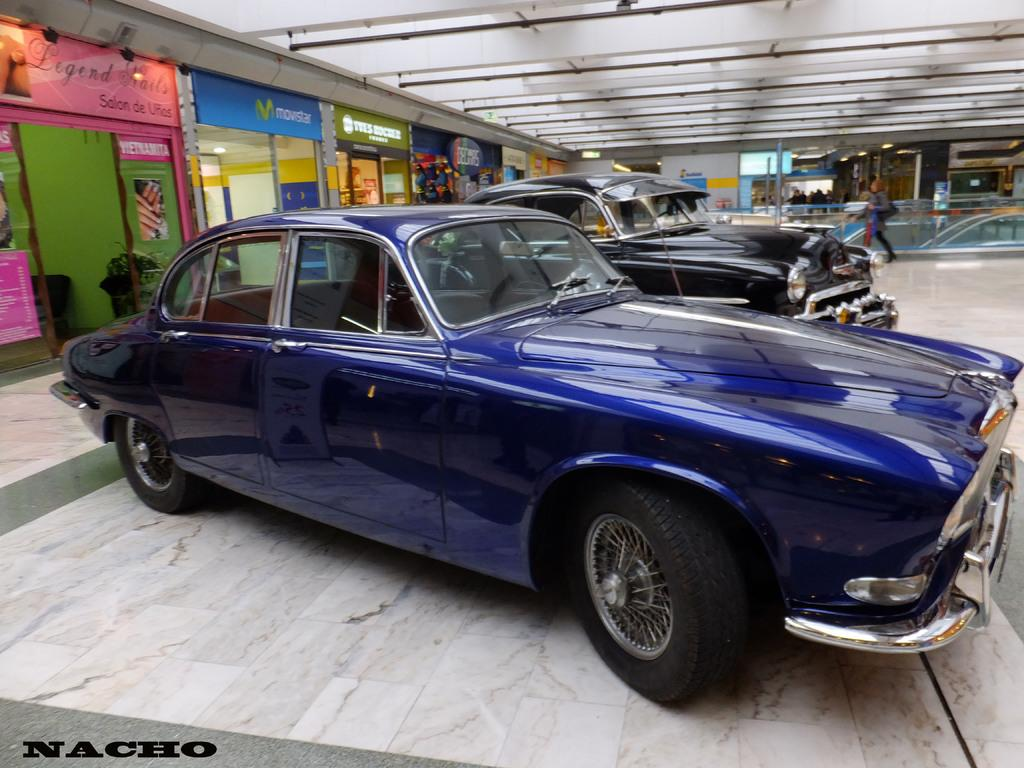What colors are the cars on the floor in the image? The cars on the floor are blue and black. What can be seen in the background of the image? There are colorful stores and boards visible in the background. What type of fencing is present in the image? There is glass fencing in the image. Can you describe the person in the image? A person is walking in the image. Where are the dolls placed in the image? There are no dolls present in the image. Can you tell me how many yaks are visible in the image? There are no yaks present in the image. 